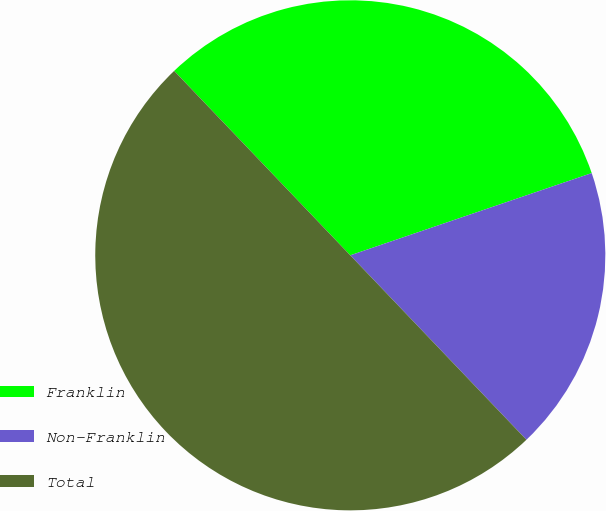<chart> <loc_0><loc_0><loc_500><loc_500><pie_chart><fcel>Franklin<fcel>Non-Franklin<fcel>Total<nl><fcel>31.91%<fcel>18.09%<fcel>50.0%<nl></chart> 